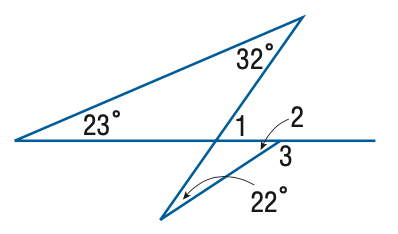Answer the mathemtical geometry problem and directly provide the correct option letter.
Question: Find the measure of \angle 3.
Choices: A: 136 B: 147 C: 148 D: 157 B 